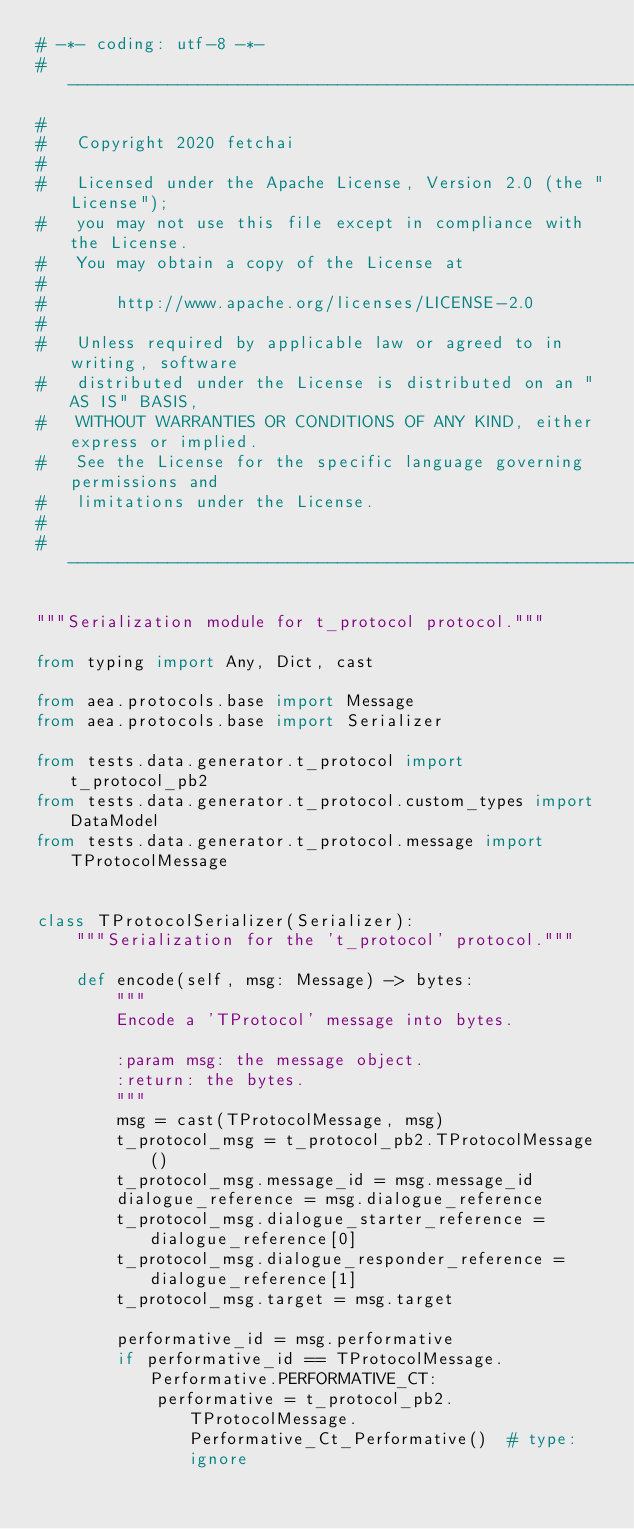<code> <loc_0><loc_0><loc_500><loc_500><_Python_># -*- coding: utf-8 -*-
# ------------------------------------------------------------------------------
#
#   Copyright 2020 fetchai
#
#   Licensed under the Apache License, Version 2.0 (the "License");
#   you may not use this file except in compliance with the License.
#   You may obtain a copy of the License at
#
#       http://www.apache.org/licenses/LICENSE-2.0
#
#   Unless required by applicable law or agreed to in writing, software
#   distributed under the License is distributed on an "AS IS" BASIS,
#   WITHOUT WARRANTIES OR CONDITIONS OF ANY KIND, either express or implied.
#   See the License for the specific language governing permissions and
#   limitations under the License.
#
# ------------------------------------------------------------------------------

"""Serialization module for t_protocol protocol."""

from typing import Any, Dict, cast

from aea.protocols.base import Message
from aea.protocols.base import Serializer

from tests.data.generator.t_protocol import t_protocol_pb2
from tests.data.generator.t_protocol.custom_types import DataModel
from tests.data.generator.t_protocol.message import TProtocolMessage


class TProtocolSerializer(Serializer):
    """Serialization for the 't_protocol' protocol."""

    def encode(self, msg: Message) -> bytes:
        """
        Encode a 'TProtocol' message into bytes.

        :param msg: the message object.
        :return: the bytes.
        """
        msg = cast(TProtocolMessage, msg)
        t_protocol_msg = t_protocol_pb2.TProtocolMessage()
        t_protocol_msg.message_id = msg.message_id
        dialogue_reference = msg.dialogue_reference
        t_protocol_msg.dialogue_starter_reference = dialogue_reference[0]
        t_protocol_msg.dialogue_responder_reference = dialogue_reference[1]
        t_protocol_msg.target = msg.target

        performative_id = msg.performative
        if performative_id == TProtocolMessage.Performative.PERFORMATIVE_CT:
            performative = t_protocol_pb2.TProtocolMessage.Performative_Ct_Performative()  # type: ignore</code> 